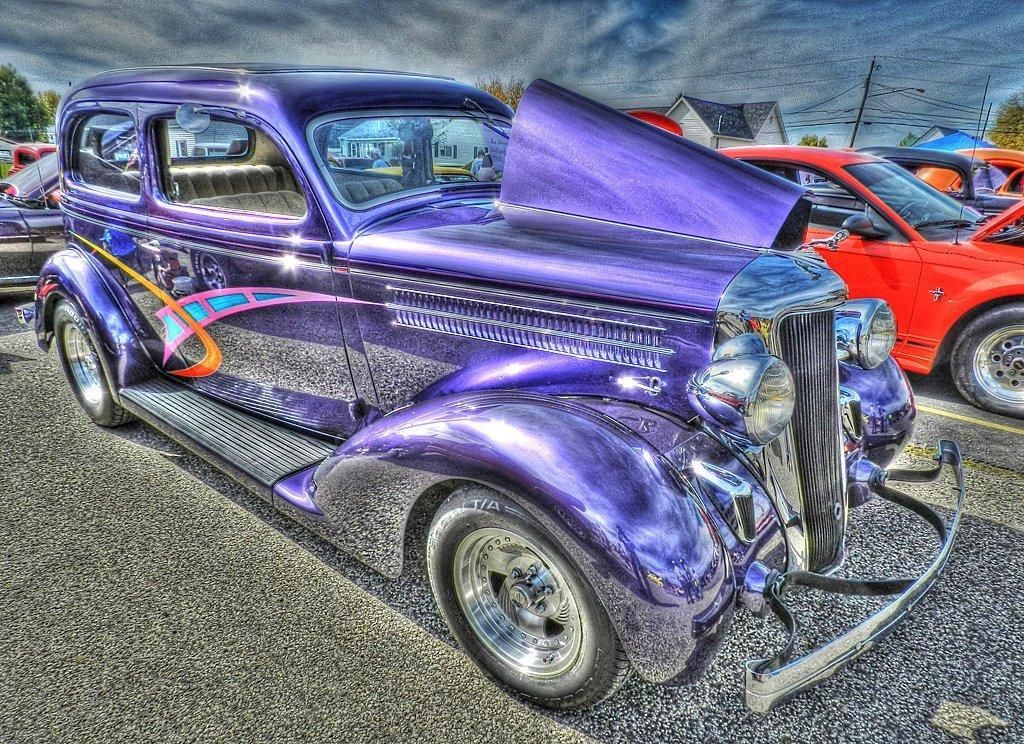Describe this image in one or two sentences. This is an animated image. In this image we can see vehicles on the road. In the back there are trees, buildings and electric poles with wires. In the background there is sky with clouds. 